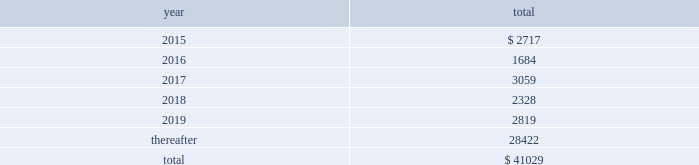Maturities of debt the scheduled maturities of the outstanding debt balances , excluding debt fair value adjustments as of december 31 , 2014 , are summarized as follows ( in millions ) : .
_______ interest rates , interest rate swaps and contingent debt the weighted average interest rate on all of our borrowings was 5.02% ( 5.02 % ) during 2014 and 5.08% ( 5.08 % ) during 2013 .
Information on our interest rate swaps is contained in note 13 .
For information about our contingent debt agreements , see note 12 .
Subsequent event subsequent to december 31 , 2014 , additional ep trust i preferred securities were converted , primarily consisting of 969117 ep trust i preferred securities converted on january 14 , 2015 , into ( i ) 697473 of our class p common stock ; ( ii ) approximately $ 24 million in cash ; and ( iii ) 1066028 in warrants .
Share-based compensation and employee benefits share-based compensation kinder morgan , inc .
Class p shares stock compensation plan for non-employee directors we have a stock compensation plan for non-employee directors , in which our eligible non-employee directors participate .
The plan recognizes that the compensation paid to each eligible non-employee director is fixed by our board , generally annually , and that the compensation is payable in cash .
Pursuant to the plan , in lieu of receiving some or all of the cash compensation , each eligible non-employee director may elect to receive shares of class p common stock .
Each election will be generally at or around the first board meeting in january of each calendar year and will be effective for the entire calendar year .
An eligible director may make a new election each calendar year .
The total number of shares of class p common stock authorized under the plan is 250000 .
During 2014 , 2013 and 2012 , we made restricted class p common stock grants to our non-employee directors of 6210 , 5710 and 5520 , respectively .
These grants were valued at time of issuance at $ 220000 , $ 210000 and $ 185000 , respectively .
All of the restricted stock grants made to non-employee directors vest during a six-month period .
Table of contents .
What percentage of total maturities of debt come due after 2019? 
Computations: (28422 / 41029)
Answer: 0.69273. 